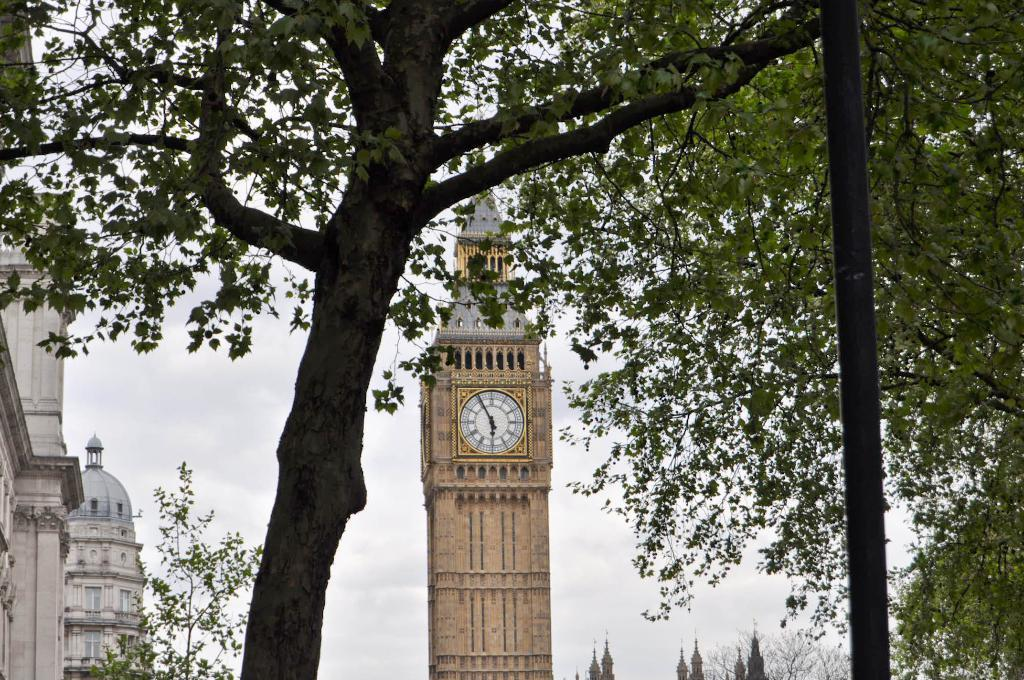What is located towards the left side of the image? There is a tree towards the left side of the image. What can be seen in the background of the image? There is a tower with a clock in the background, along with buildings and trees. What type of stem can be seen growing from the top of the tree in the image? There is no stem growing from the top of the tree in the image, as trees typically do not have stems. 